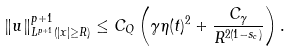Convert formula to latex. <formula><loc_0><loc_0><loc_500><loc_500>\| u \| _ { L ^ { p + 1 } ( | x | \geq R ) } ^ { p + 1 } \leq C _ { Q } \left ( \gamma \eta ( t ) ^ { 2 } + \frac { C _ { \gamma } } { R ^ { 2 ( 1 - s _ { c } ) } } \right ) .</formula> 